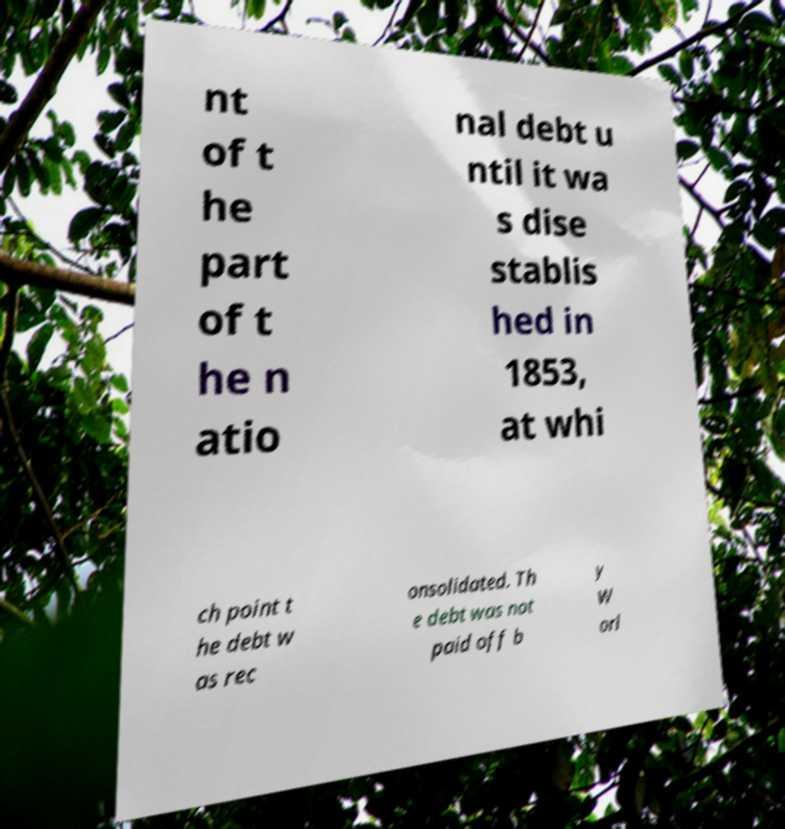Can you read and provide the text displayed in the image?This photo seems to have some interesting text. Can you extract and type it out for me? nt of t he part of t he n atio nal debt u ntil it wa s dise stablis hed in 1853, at whi ch point t he debt w as rec onsolidated. Th e debt was not paid off b y W orl 